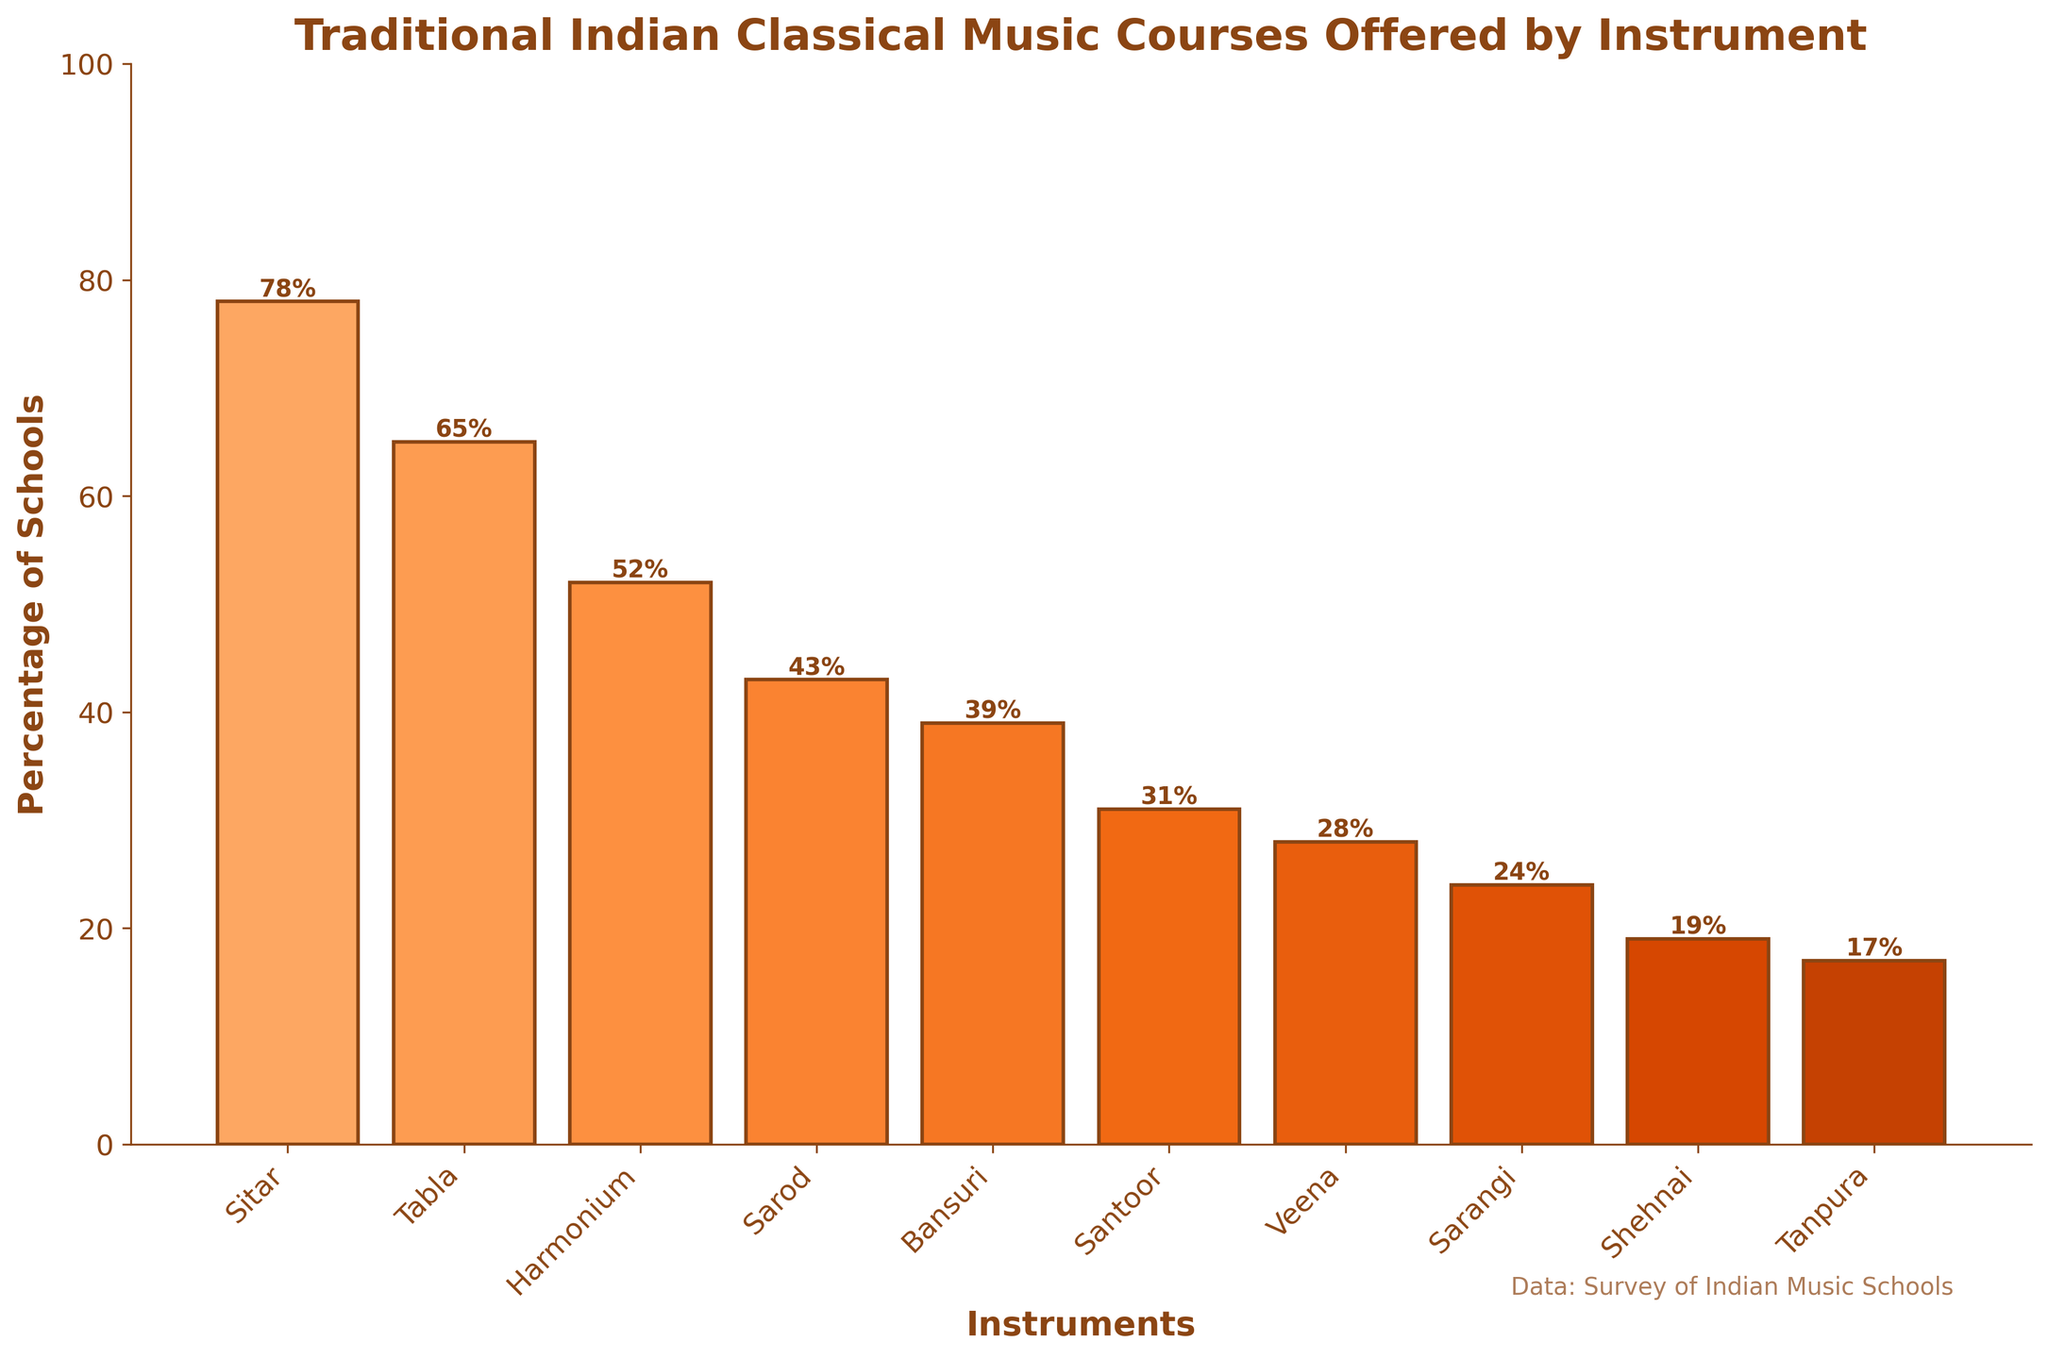What percentage of music schools offer Sitar courses? The percentage of music schools offering Sitar courses is directly shown on the bar chart. It indicates 78%.
Answer: 78% Which instrument has the lowest percentage of schools offering courses? By observing the heights of the bars, Tanpura has the lowest bar, indicating the smallest percentage.
Answer: Tanpura How many more schools offer Sitar courses compared to Shehnai courses? The percentage of schools offering Sitar courses is 78%, while for Shehnai it is 19%. The difference can be calculated as 78% - 19% = 59%.
Answer: 59% What is the percentage difference between Tabla and Harmonium courses in music schools? The bar for Tabla courses shows 65%, and Harmonium shows 52%. The difference is 65% - 52% = 13%.
Answer: 13% Which instrument has a higher percentage of courses offered in music schools, Sarod or Bansuri? The bars for Sarod and Bansuri show 43% and 39%, respectively. Since 43% is greater than 39%, Sarod has a higher percentage.
Answer: Sarod What are the three instruments with the highest percentage of schools offering courses? The tallest bars represent the highest percentages. They are for Sitar (78%), Tabla (65%), and Harmonium (52%).
Answer: Sitar, Tabla, Harmonium What is the average percentage of schools offering courses for Sitar, Sarod, and Veena? The percentages are 78% for Sitar, 43% for Sarod, and 28% for Veena. The average is calculated as (78% + 43% + 28%) / 3 = 149% / 3 = 49.67%.
Answer: 49.67% Which has more courses offered, Santoor or Tanpura, and by how much? The percentage for Santoor is 31%, and for Tanpura, it is 17%. The difference is 31% - 17% = 14%. Santoor has more.
Answer: Santoor, 14% Are there more music schools offering Sarangi or Harmonium courses? By comparing the bar heights, Harmonium at 52% is more than Sarangi at 24%.
Answer: Harmonium 